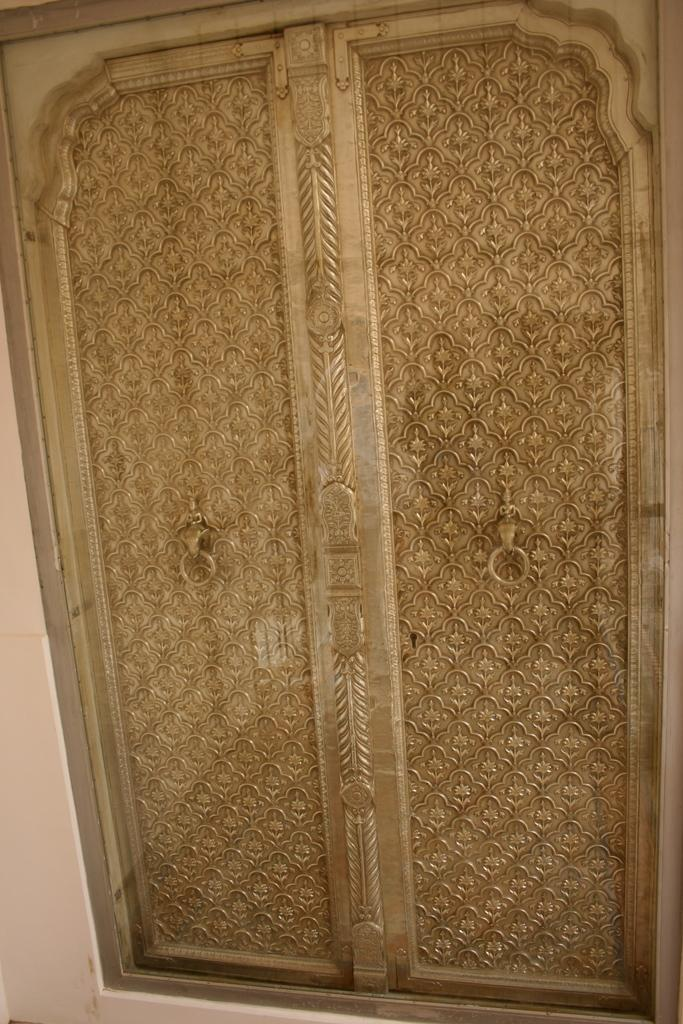What is the main object in the image? There is a door in the image. Reasoning: Let's think step by step by step in order to produce the conversation. We start by identifying the main subject in the image, which is the door. Since there is only one fact provided, we formulate a question that focuses on the location and characteristics of this subject, ensuring that each question can be answered definitively with the information given. We avoid yes/no questions and ensure that the language is simple and clear. Absurd Question/Answer: What type of glue is being used by the queen in the image? There is no queen or glue present in the image; it only features a door. What sound does the alarm make in the image? There is no alarm present in the image; it only features a door. What type of glue is being used by the queen in the image? There is no queen or glue present in the image; it only features a door. What sound does the alarm make in the image? There is no alarm present in the image; it only features a door. 